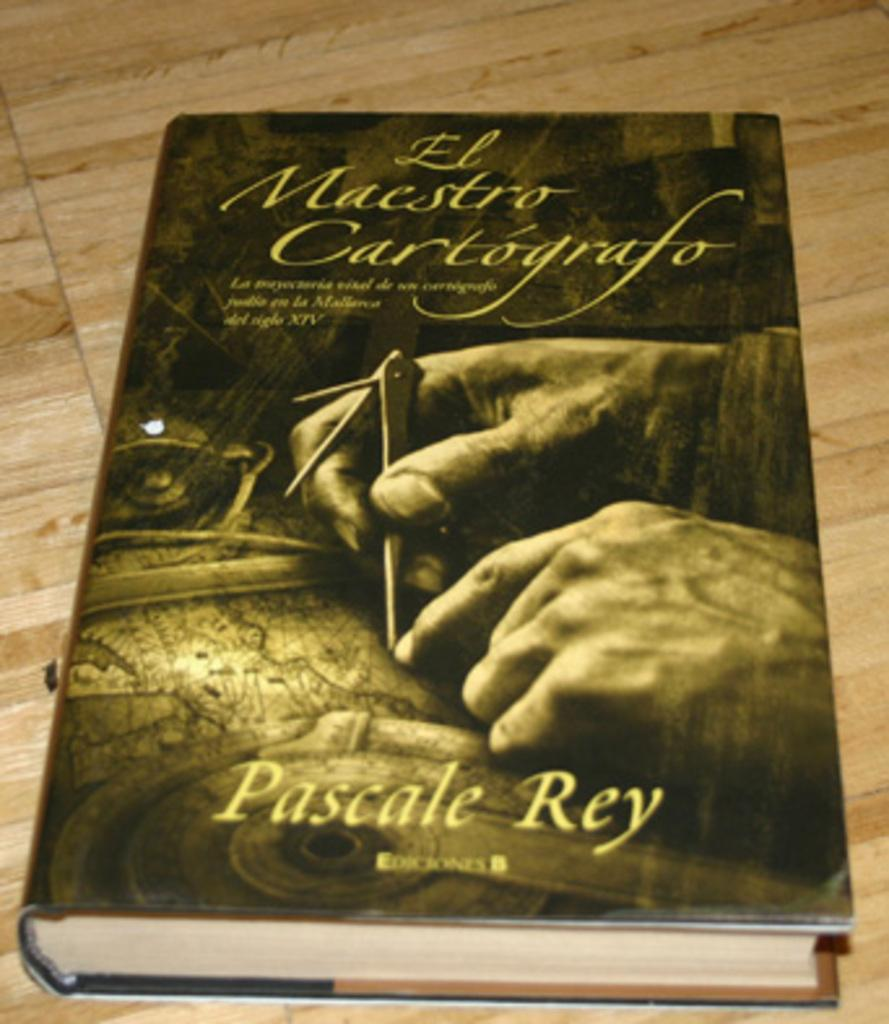<image>
Offer a succinct explanation of the picture presented. A book that is titled El Maestro Cartografo. 